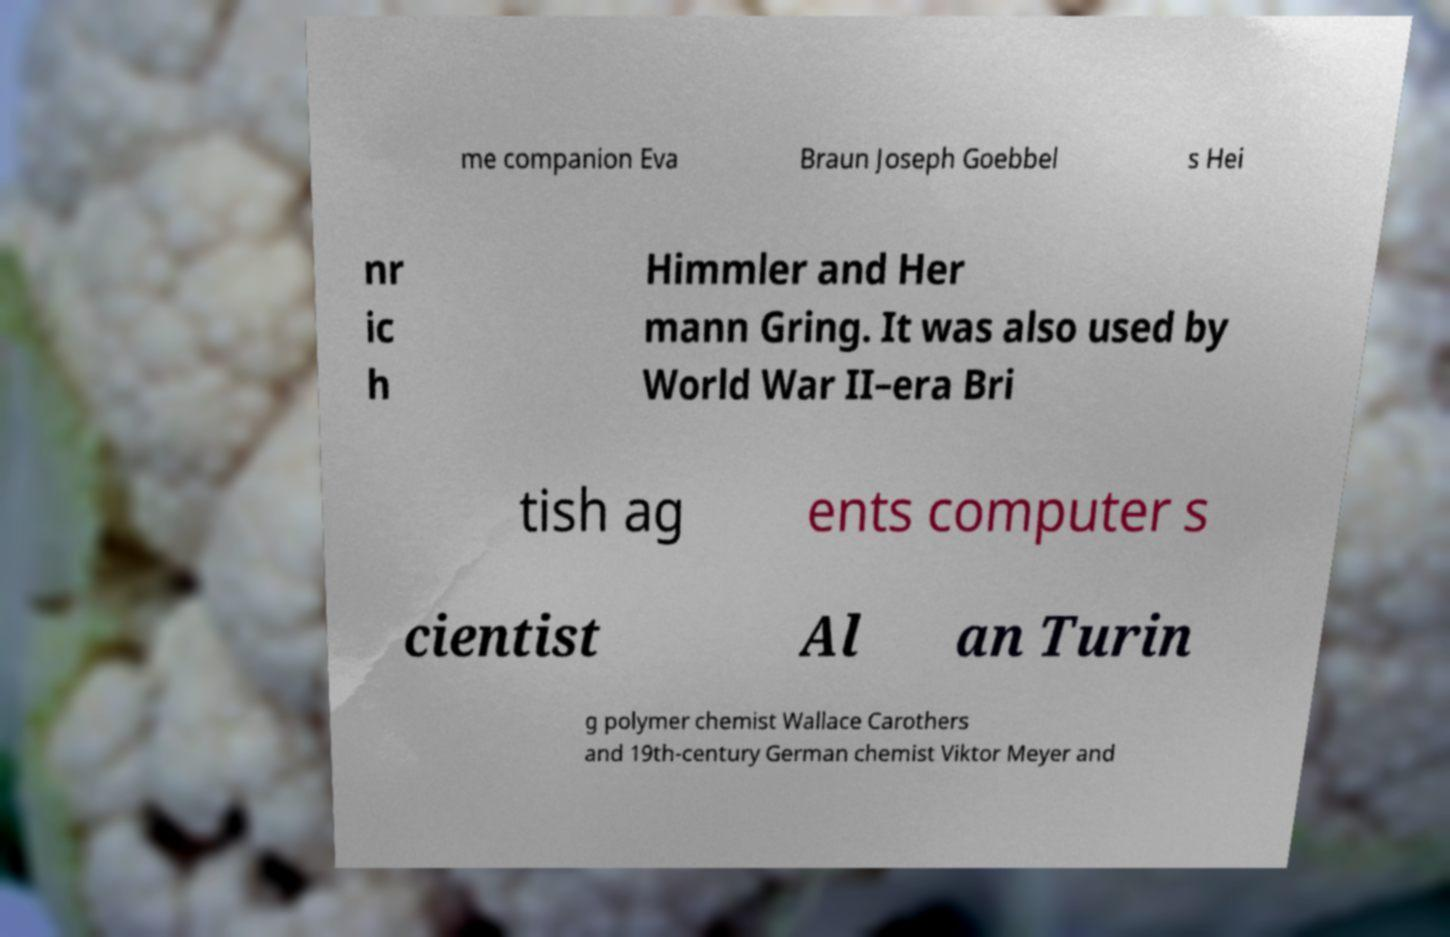Could you extract and type out the text from this image? me companion Eva Braun Joseph Goebbel s Hei nr ic h Himmler and Her mann Gring. It was also used by World War II–era Bri tish ag ents computer s cientist Al an Turin g polymer chemist Wallace Carothers and 19th-century German chemist Viktor Meyer and 